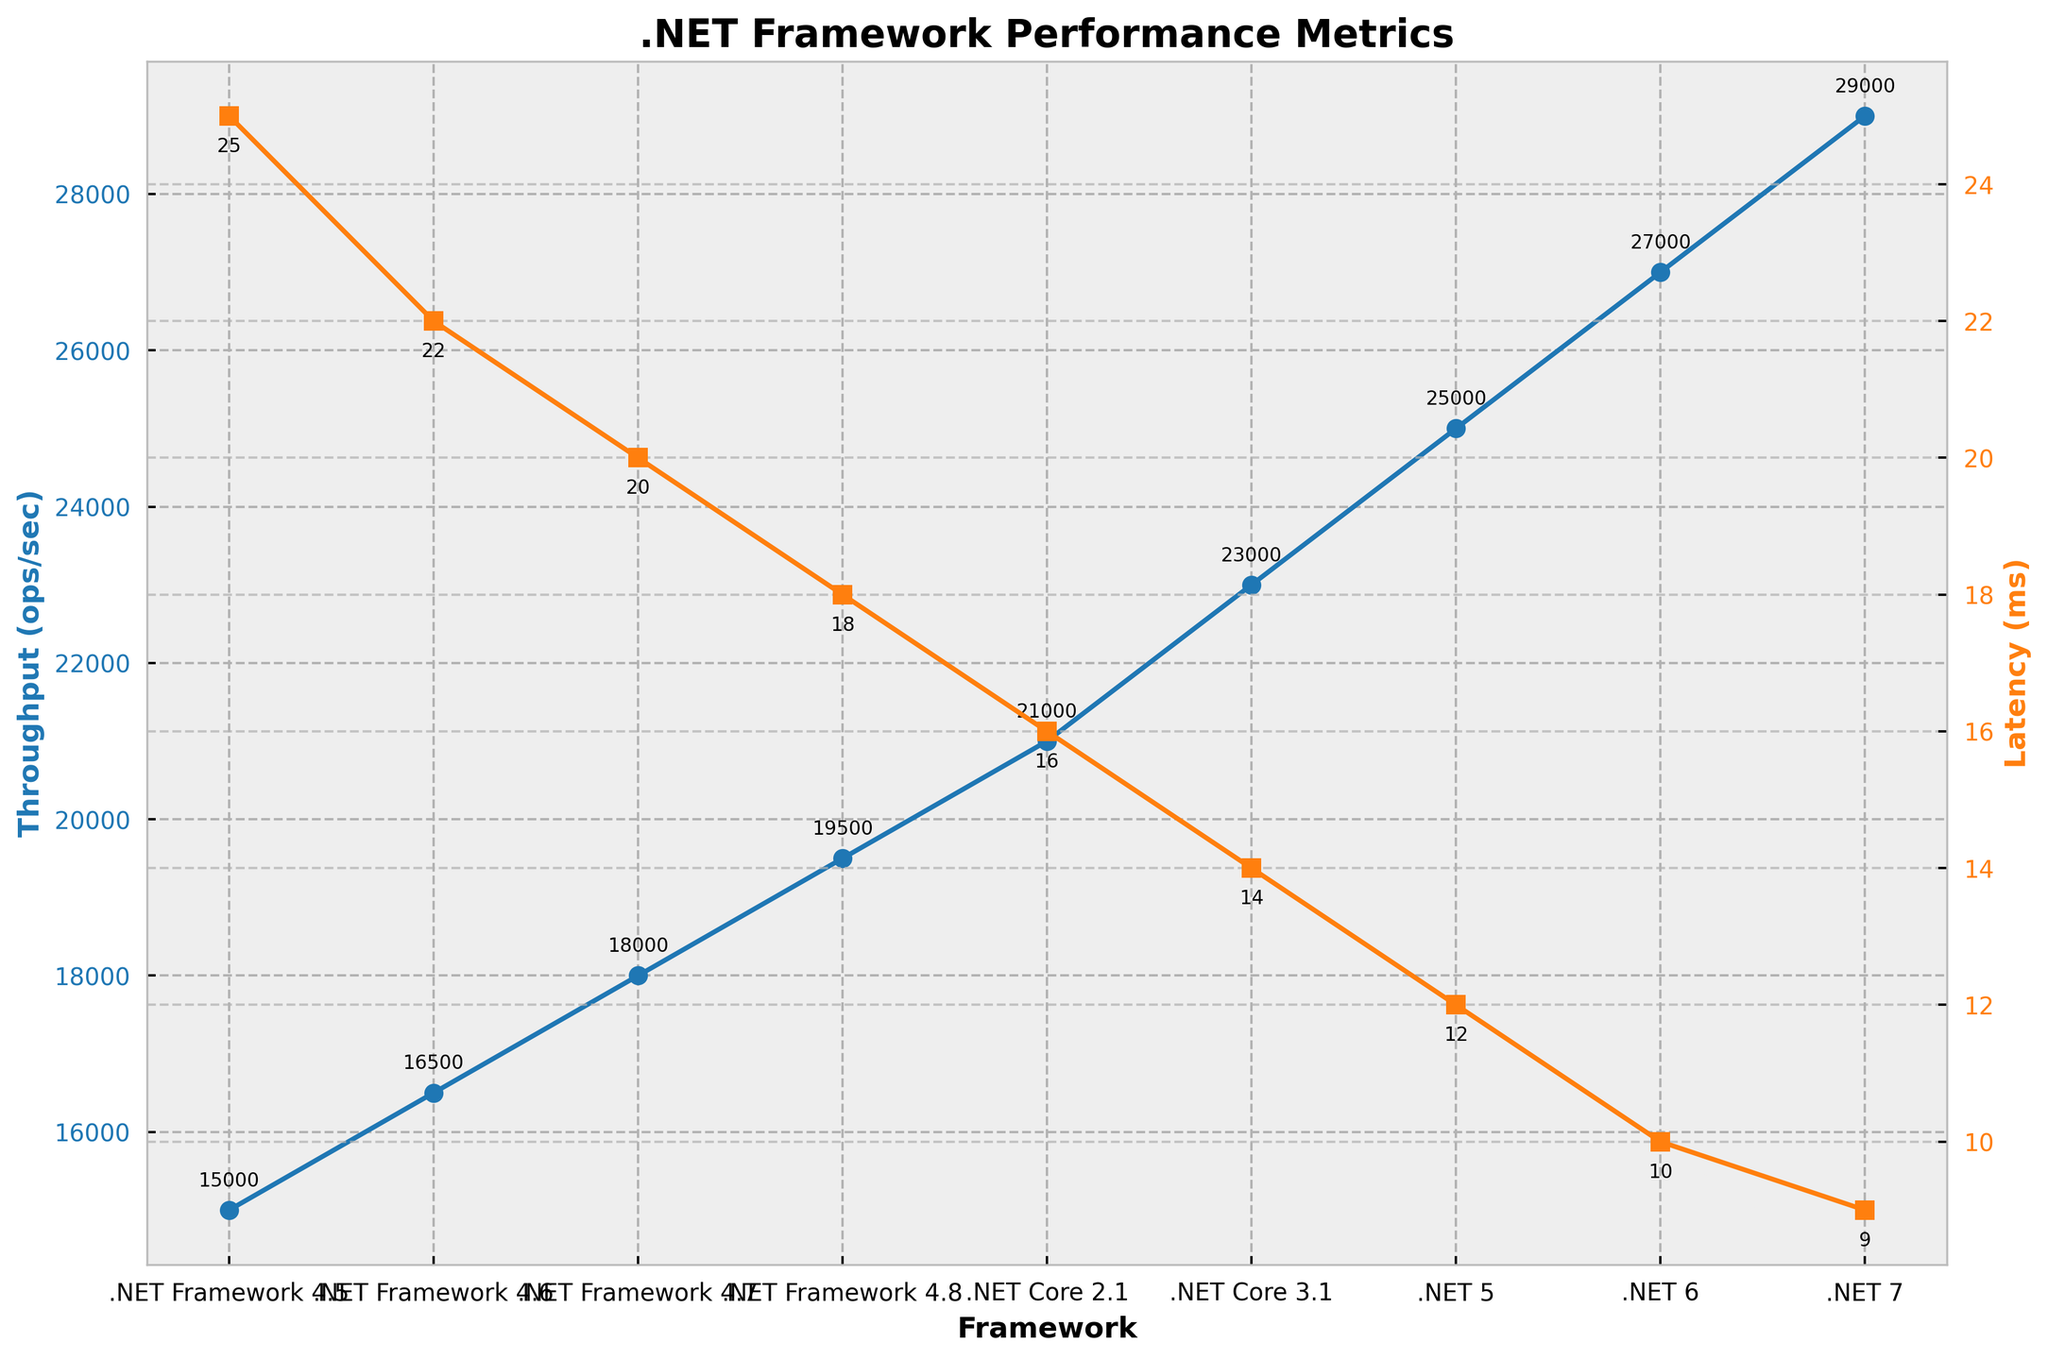What's the trend of throughput from .NET Framework 4.5 to .NET 7? The trend of throughput shows a steady increase from .NET Framework 4.5 to .NET 7. The throughput starts at 15,000 ops/sec in .NET Framework 4.5 and rises consistently up to 29,000 ops/sec in .NET 7.
Answer: Steady increase Which framework version shows the lowest latency? To find the lowest latency, look at the "Latency (ms)" values for each framework version. The lowest value observed is 9 ms, which corresponds to .NET 7.
Answer: .NET 7 What is the difference in throughput between .NET Core 3.1 and .NET 7? The throughput for .NET Core 3.1 is 23,000 ops/sec and for .NET 7 is 29,000 ops/sec. The difference can be calculated as 29,000 - 23,000 = 6,000 ops/sec.
Answer: 6,000 ops/sec Compare the CPU usage between .NET Framework 4.5 and .NET 7. The CPU usage for .NET Framework 4.5 is 65% and for .NET 7 is 84%. Thus, .NET 7 uses more CPU by a margin of 84% - 65% = 19%.
Answer: .NET 7 uses 19% more Which framework has the highest increase in thread pool growth time compared to its immediate predecessor? Comparing the "Thread Pool Growth Time (ms)" values incrementally, the largest increase is observed from .NET Framework 4.8 to .NET Core 2.1, where it jumps by 120 - 110 = 110 ms.
Answer: .NET Core 2.1 What is the combined throughput of all .NET Core versions? Sum the throughput values for .NET Core 2.1, .NET Core 3.1, and .NET 5: 21,000 + 23,000 + 25,000 = 69,000 ops/sec.
Answer: 69,000 ops/sec How does the latency change visually from .NET Framework to .NET 7? Visually, the latency line is orange and shows a decreasing trend from .NET Framework 4.5 (25 ms) to .NET 7 (9 ms), indicating reducing latency across versions.
Answer: Decreasing trend Do context switches/sec increase or decrease over time from .NET Framework 4.5 to .NET 7? The context switches/sec, which are not directly plotted, increase from 5,000/sec in .NET Framework 4.5 to 9,000/sec in .NET 7.
Answer: Increase By how much does the maximum number of threads grow from .NET Framework 4.5 to .NET 7? The maximum number of threads for .NET Framework 4.5 is 250, and for .NET 7 it is 450. The growth is 450 - 250 = 200 threads.
Answer: 200 threads 